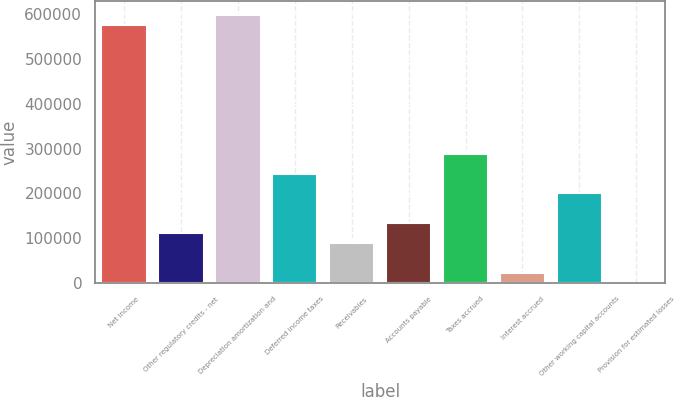Convert chart to OTSL. <chart><loc_0><loc_0><loc_500><loc_500><bar_chart><fcel>Net income<fcel>Other regulatory credits - net<fcel>Depreciation amortization and<fcel>Deferred income taxes<fcel>Receivables<fcel>Accounts payable<fcel>Taxes accrued<fcel>Interest accrued<fcel>Other working capital accounts<fcel>Provision for estimated losses<nl><fcel>576867<fcel>110974<fcel>599053<fcel>244086<fcel>88788.6<fcel>133159<fcel>288457<fcel>22232.4<fcel>199716<fcel>47<nl></chart> 